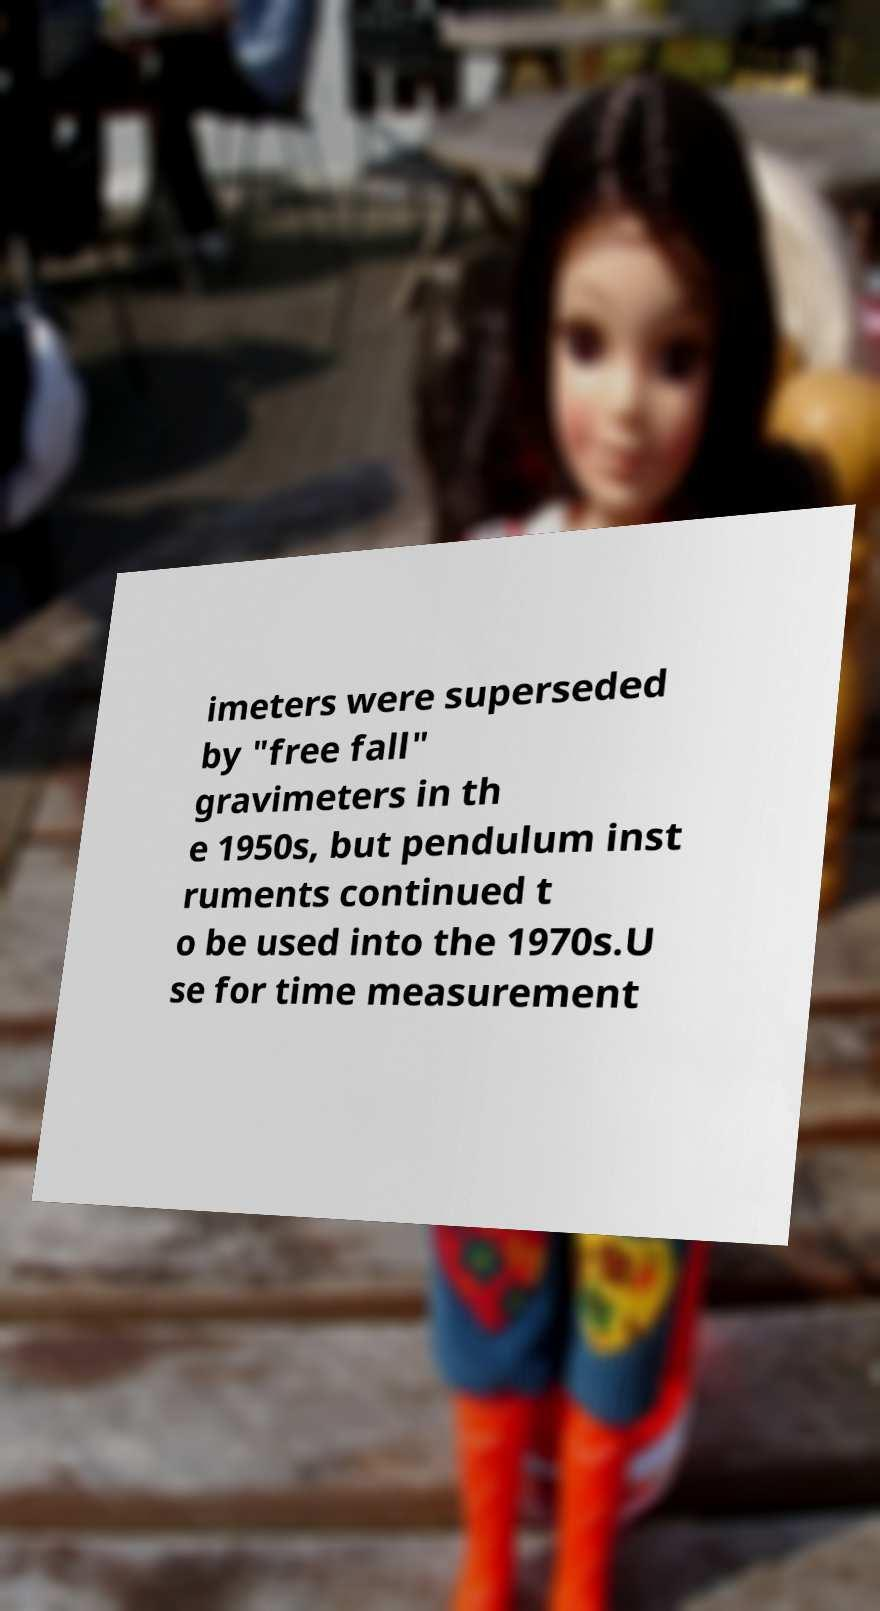Please identify and transcribe the text found in this image. imeters were superseded by "free fall" gravimeters in th e 1950s, but pendulum inst ruments continued t o be used into the 1970s.U se for time measurement 